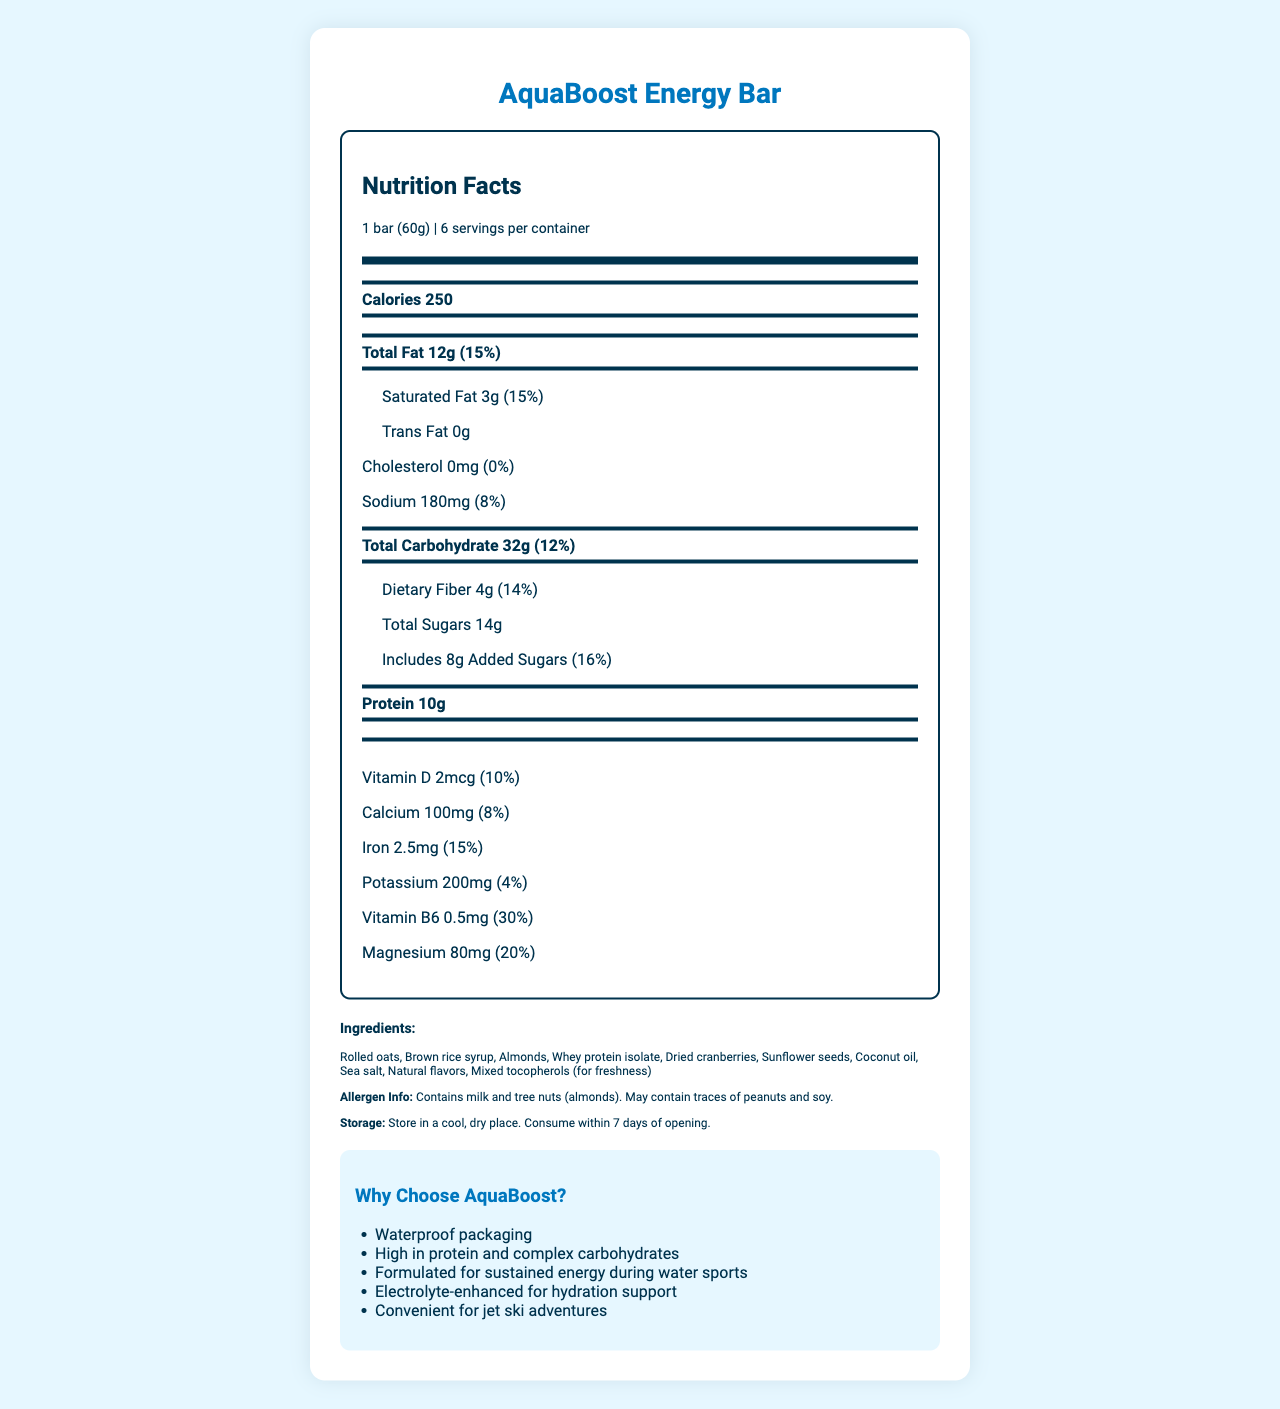what is the serving size of AquaBoost Energy Bar? The serving size is explicitly mentioned at the beginning of the nutrition facts.
Answer: 1 bar (60g) how many servings are there per container? The document specifies that there are 6 servings per container.
Answer: 6 what is the total fat content per serving? The total fat content is listed as 12g on the nutrition facts label.
Answer: 12g what percentage of the daily value of iron does one bar provide? The daily value percentage of iron is indicated as 15%.
Answer: 15% what allergens are present in the AquaBoost Energy Bar? The allergen information section mentions that the bar contains milk and tree nuts (almonds).
Answer: Milk and tree nuts (almonds) What is the amount of protein in one bar? A. 5g B. 10g C. 15g D. 20g The label indicates that one bar contains 10g of protein.
Answer: B How much potassium is in one bar? A. 100mg B. 150mg C. 200mg D. 250mg The document states there is 200mg of potassium per bar.
Answer: C is there any cholesterol in the AquaBoost Energy Bar? The label shows there is 0mg of cholesterol.
Answer: No Summarize the main marketing claims of the AquaBoost Energy Bar. The marketing claims section lists several reasons why AquaBoost is beneficial, highlighting its suitability for water sports and convenience.
Answer: Waterproof packaging, high in protein and complex carbohydrates, formulated for sustained energy during water sports, electrolyte-enhanced for hydration support, convenient for jet ski adventures. how many grams of added sugars does one bar include? The label specifies that there are 8g of added sugars in one bar.
Answer: 8g What is the main ingredient in AquaBoost Energy Bar? The ingredients list starts with rolled oats, indicating it is the main ingredient.
Answer: Rolled oats does the AquaBoost Energy Bar contain any trans fat? The label shows 0g of trans fat per serving.
Answer: No What are the storage instructions for the AquaBoost Energy Bar? The storage instructions state that the bar should be stored in a cool, dry place and consumed within 7 days of opening.
Answer: Store in a cool, dry place. Consume within 7 days of opening. How much calcium does one bar provide in terms of daily value percentage? A. 8% B. 10% C. 15% D. 20% The document lists the daily value percentage of calcium as 8%.
Answer: A What is the calorie count per bar? The calorie count is clearly stated as 250 calories per serving.
Answer: 250 how many grams of dietary fiber are in one bar? The label specifies that each bar contains 4g of dietary fiber.
Answer: 4g How much of Vitamin B6 is there in a bar in terms of daily value? The document lists Vitamin B6 at 30% of the daily value.
Answer: 30% are the energy bars gluten-free? The document does not specify whether the bars are gluten-free.
Answer: Not enough information Why is AquaBoost marketed as suitable for water sports? These benefits are mentioned in the marketing claims, emphasizing aspects that make it suitable for water sports.
Answer: Waterproof packaging, high protein and complex carbohydrates, sustained energy, electrolyte-enhanced, convenient for jet ski adventures 